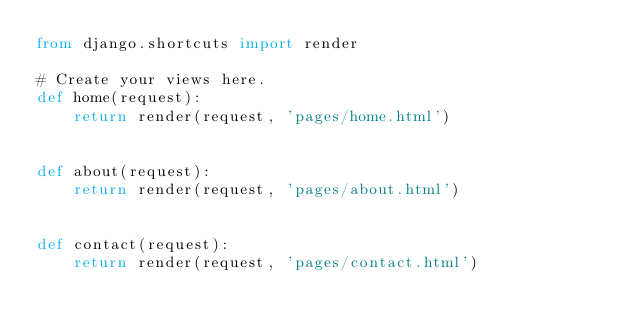<code> <loc_0><loc_0><loc_500><loc_500><_Python_>from django.shortcuts import render

# Create your views here.
def home(request):
    return render(request, 'pages/home.html')


def about(request):
    return render(request, 'pages/about.html')


def contact(request):
    return render(request, 'pages/contact.html')
</code> 